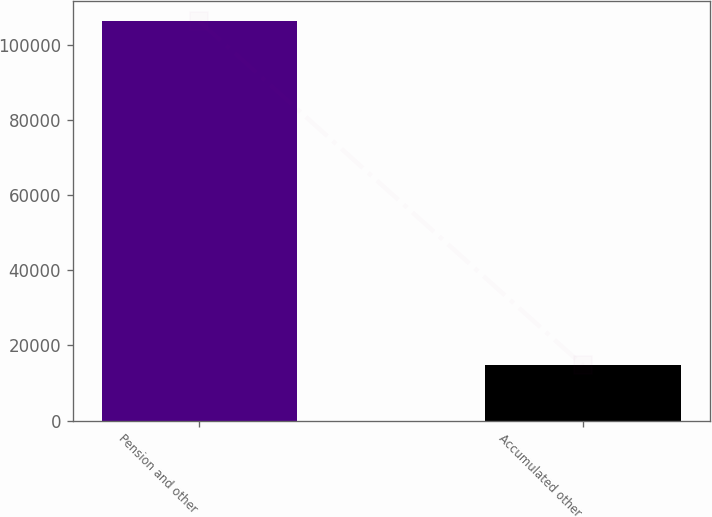Convert chart to OTSL. <chart><loc_0><loc_0><loc_500><loc_500><bar_chart><fcel>Pension and other<fcel>Accumulated other<nl><fcel>106155<fcel>14638<nl></chart> 